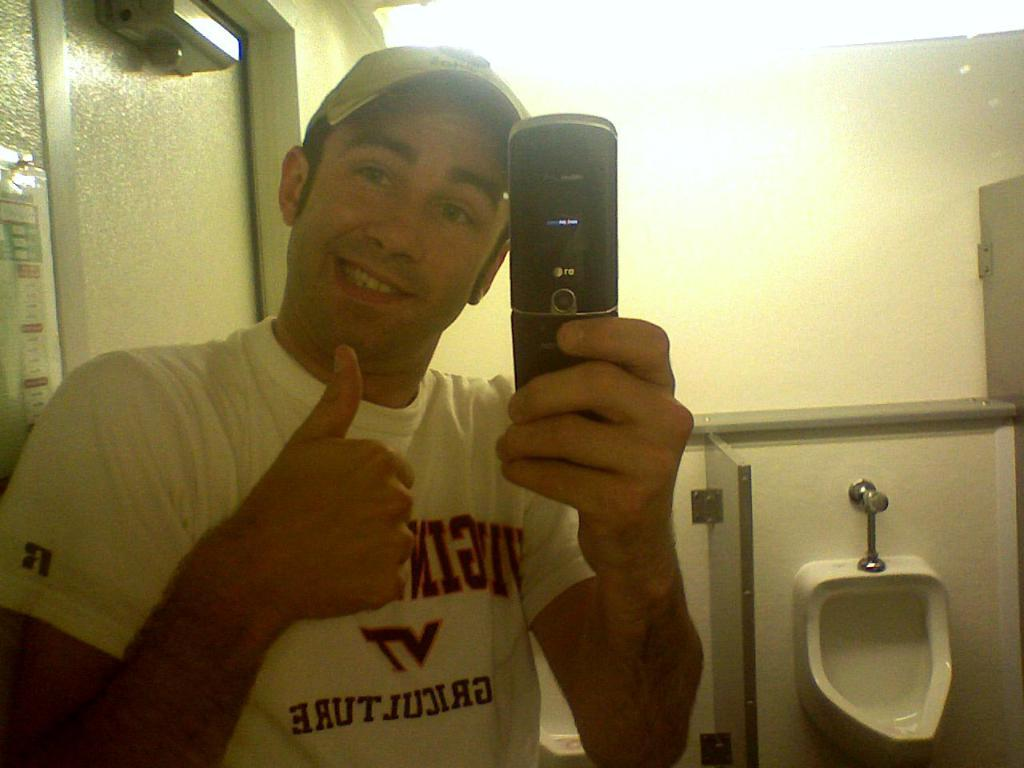Who is present in the image? There is a man in the image. Where is the man located in the image? The man is standing at the left side of the image. What is the man holding in his hand? The man is holding a cell phone in his hand. What type of stone can be seen falling from the sky during the rainstorm in the image? There is no rainstorm or stone present in the image; it features a man standing at the left side holding a cell phone. 